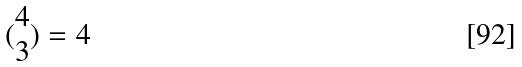<formula> <loc_0><loc_0><loc_500><loc_500>( \begin{matrix} 4 \\ 3 \end{matrix} ) = 4</formula> 